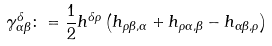<formula> <loc_0><loc_0><loc_500><loc_500>\gamma ^ { \delta } _ { \alpha \beta } \colon = \frac { 1 } { 2 } h ^ { \delta \rho } \left ( h _ { \rho \beta , \alpha } + h _ { \rho \alpha , \beta } - h _ { \alpha \beta , \rho } \right )</formula> 